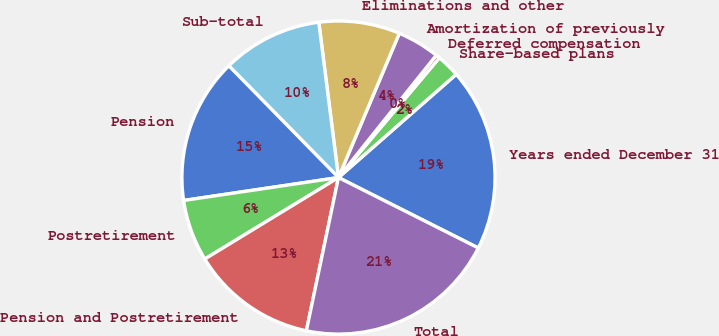<chart> <loc_0><loc_0><loc_500><loc_500><pie_chart><fcel>Years ended December 31<fcel>Share-based plans<fcel>Deferred compensation<fcel>Amortization of previously<fcel>Eliminations and other<fcel>Sub-total<fcel>Pension<fcel>Postretirement<fcel>Pension and Postretirement<fcel>Total<nl><fcel>18.88%<fcel>2.4%<fcel>0.41%<fcel>4.38%<fcel>8.36%<fcel>10.34%<fcel>14.99%<fcel>6.37%<fcel>13.0%<fcel>20.86%<nl></chart> 